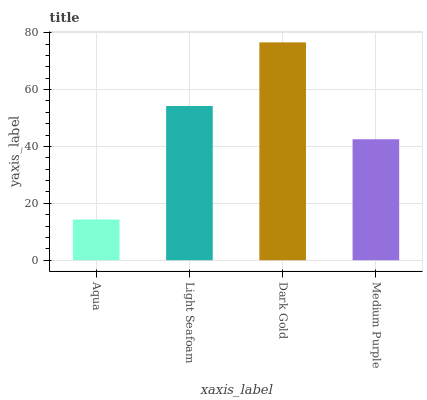Is Aqua the minimum?
Answer yes or no. Yes. Is Dark Gold the maximum?
Answer yes or no. Yes. Is Light Seafoam the minimum?
Answer yes or no. No. Is Light Seafoam the maximum?
Answer yes or no. No. Is Light Seafoam greater than Aqua?
Answer yes or no. Yes. Is Aqua less than Light Seafoam?
Answer yes or no. Yes. Is Aqua greater than Light Seafoam?
Answer yes or no. No. Is Light Seafoam less than Aqua?
Answer yes or no. No. Is Light Seafoam the high median?
Answer yes or no. Yes. Is Medium Purple the low median?
Answer yes or no. Yes. Is Dark Gold the high median?
Answer yes or no. No. Is Light Seafoam the low median?
Answer yes or no. No. 